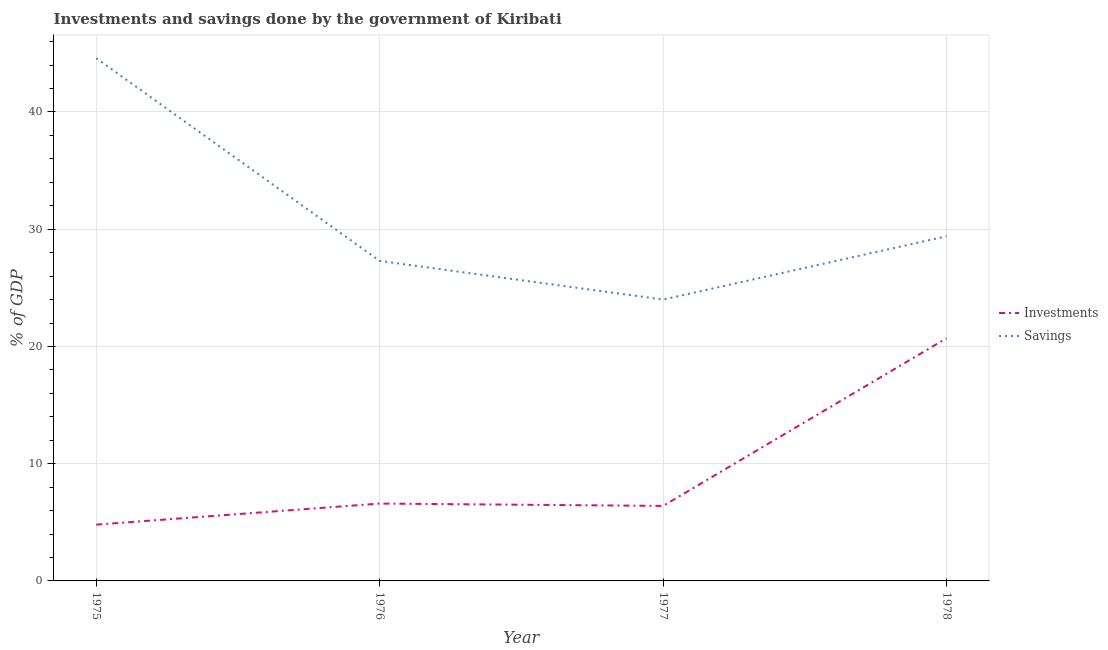How many different coloured lines are there?
Your response must be concise. 2. Does the line corresponding to investments of government intersect with the line corresponding to savings of government?
Make the answer very short. No. What is the savings of government in 1978?
Your answer should be very brief. 29.4. Across all years, what is the maximum investments of government?
Give a very brief answer. 20.7. Across all years, what is the minimum investments of government?
Provide a succinct answer. 4.8. In which year was the savings of government maximum?
Give a very brief answer. 1975. In which year was the investments of government minimum?
Your response must be concise. 1975. What is the total investments of government in the graph?
Keep it short and to the point. 38.5. What is the difference between the savings of government in 1977 and that in 1978?
Give a very brief answer. -5.4. What is the difference between the investments of government in 1975 and the savings of government in 1977?
Make the answer very short. -19.2. What is the average savings of government per year?
Provide a succinct answer. 31.32. In the year 1978, what is the difference between the investments of government and savings of government?
Offer a very short reply. -8.7. What is the ratio of the savings of government in 1976 to that in 1977?
Your response must be concise. 1.14. Is the investments of government in 1976 less than that in 1977?
Your answer should be very brief. No. What is the difference between the highest and the second highest savings of government?
Ensure brevity in your answer.  15.19. What is the difference between the highest and the lowest investments of government?
Offer a very short reply. 15.9. In how many years, is the investments of government greater than the average investments of government taken over all years?
Ensure brevity in your answer.  1. Is the savings of government strictly less than the investments of government over the years?
Your answer should be very brief. No. How many lines are there?
Ensure brevity in your answer.  2. How many years are there in the graph?
Your answer should be very brief. 4. Are the values on the major ticks of Y-axis written in scientific E-notation?
Provide a short and direct response. No. Does the graph contain any zero values?
Your answer should be compact. No. Where does the legend appear in the graph?
Ensure brevity in your answer.  Center right. What is the title of the graph?
Provide a succinct answer. Investments and savings done by the government of Kiribati. What is the label or title of the Y-axis?
Make the answer very short. % of GDP. What is the % of GDP of Investments in 1975?
Give a very brief answer. 4.8. What is the % of GDP in Savings in 1975?
Offer a very short reply. 44.59. What is the % of GDP of Investments in 1976?
Your response must be concise. 6.6. What is the % of GDP in Savings in 1976?
Ensure brevity in your answer.  27.3. What is the % of GDP in Investments in 1977?
Make the answer very short. 6.4. What is the % of GDP in Savings in 1977?
Offer a terse response. 24. What is the % of GDP in Investments in 1978?
Give a very brief answer. 20.7. What is the % of GDP in Savings in 1978?
Your answer should be compact. 29.4. Across all years, what is the maximum % of GDP in Investments?
Your answer should be compact. 20.7. Across all years, what is the maximum % of GDP in Savings?
Your response must be concise. 44.59. Across all years, what is the minimum % of GDP in Investments?
Your answer should be very brief. 4.8. Across all years, what is the minimum % of GDP in Savings?
Offer a very short reply. 24. What is the total % of GDP of Investments in the graph?
Your response must be concise. 38.5. What is the total % of GDP of Savings in the graph?
Keep it short and to the point. 125.28. What is the difference between the % of GDP of Investments in 1975 and that in 1976?
Your answer should be compact. -1.8. What is the difference between the % of GDP in Savings in 1975 and that in 1976?
Ensure brevity in your answer.  17.29. What is the difference between the % of GDP of Investments in 1975 and that in 1977?
Offer a terse response. -1.6. What is the difference between the % of GDP in Savings in 1975 and that in 1977?
Provide a succinct answer. 20.59. What is the difference between the % of GDP in Investments in 1975 and that in 1978?
Offer a terse response. -15.9. What is the difference between the % of GDP in Savings in 1975 and that in 1978?
Provide a succinct answer. 15.19. What is the difference between the % of GDP in Investments in 1976 and that in 1977?
Your response must be concise. 0.2. What is the difference between the % of GDP in Savings in 1976 and that in 1977?
Your response must be concise. 3.3. What is the difference between the % of GDP of Investments in 1976 and that in 1978?
Keep it short and to the point. -14.1. What is the difference between the % of GDP in Savings in 1976 and that in 1978?
Offer a terse response. -2.1. What is the difference between the % of GDP of Investments in 1977 and that in 1978?
Provide a short and direct response. -14.3. What is the difference between the % of GDP in Savings in 1977 and that in 1978?
Keep it short and to the point. -5.4. What is the difference between the % of GDP in Investments in 1975 and the % of GDP in Savings in 1976?
Your response must be concise. -22.5. What is the difference between the % of GDP in Investments in 1975 and the % of GDP in Savings in 1977?
Offer a very short reply. -19.2. What is the difference between the % of GDP of Investments in 1975 and the % of GDP of Savings in 1978?
Provide a short and direct response. -24.6. What is the difference between the % of GDP in Investments in 1976 and the % of GDP in Savings in 1977?
Make the answer very short. -17.4. What is the difference between the % of GDP in Investments in 1976 and the % of GDP in Savings in 1978?
Provide a short and direct response. -22.8. What is the difference between the % of GDP in Investments in 1977 and the % of GDP in Savings in 1978?
Provide a short and direct response. -23. What is the average % of GDP in Investments per year?
Make the answer very short. 9.62. What is the average % of GDP of Savings per year?
Your response must be concise. 31.32. In the year 1975, what is the difference between the % of GDP in Investments and % of GDP in Savings?
Offer a terse response. -39.79. In the year 1976, what is the difference between the % of GDP of Investments and % of GDP of Savings?
Your response must be concise. -20.7. In the year 1977, what is the difference between the % of GDP of Investments and % of GDP of Savings?
Make the answer very short. -17.6. In the year 1978, what is the difference between the % of GDP in Investments and % of GDP in Savings?
Ensure brevity in your answer.  -8.7. What is the ratio of the % of GDP in Investments in 1975 to that in 1976?
Keep it short and to the point. 0.73. What is the ratio of the % of GDP in Savings in 1975 to that in 1976?
Offer a terse response. 1.63. What is the ratio of the % of GDP in Investments in 1975 to that in 1977?
Your response must be concise. 0.75. What is the ratio of the % of GDP in Savings in 1975 to that in 1977?
Your answer should be compact. 1.86. What is the ratio of the % of GDP of Investments in 1975 to that in 1978?
Give a very brief answer. 0.23. What is the ratio of the % of GDP in Savings in 1975 to that in 1978?
Give a very brief answer. 1.52. What is the ratio of the % of GDP in Investments in 1976 to that in 1977?
Give a very brief answer. 1.03. What is the ratio of the % of GDP in Savings in 1976 to that in 1977?
Ensure brevity in your answer.  1.14. What is the ratio of the % of GDP in Investments in 1976 to that in 1978?
Provide a short and direct response. 0.32. What is the ratio of the % of GDP of Savings in 1976 to that in 1978?
Make the answer very short. 0.93. What is the ratio of the % of GDP in Investments in 1977 to that in 1978?
Your answer should be very brief. 0.31. What is the ratio of the % of GDP in Savings in 1977 to that in 1978?
Offer a very short reply. 0.82. What is the difference between the highest and the second highest % of GDP of Investments?
Provide a short and direct response. 14.1. What is the difference between the highest and the second highest % of GDP of Savings?
Your answer should be compact. 15.19. What is the difference between the highest and the lowest % of GDP of Investments?
Provide a succinct answer. 15.9. What is the difference between the highest and the lowest % of GDP in Savings?
Ensure brevity in your answer.  20.59. 